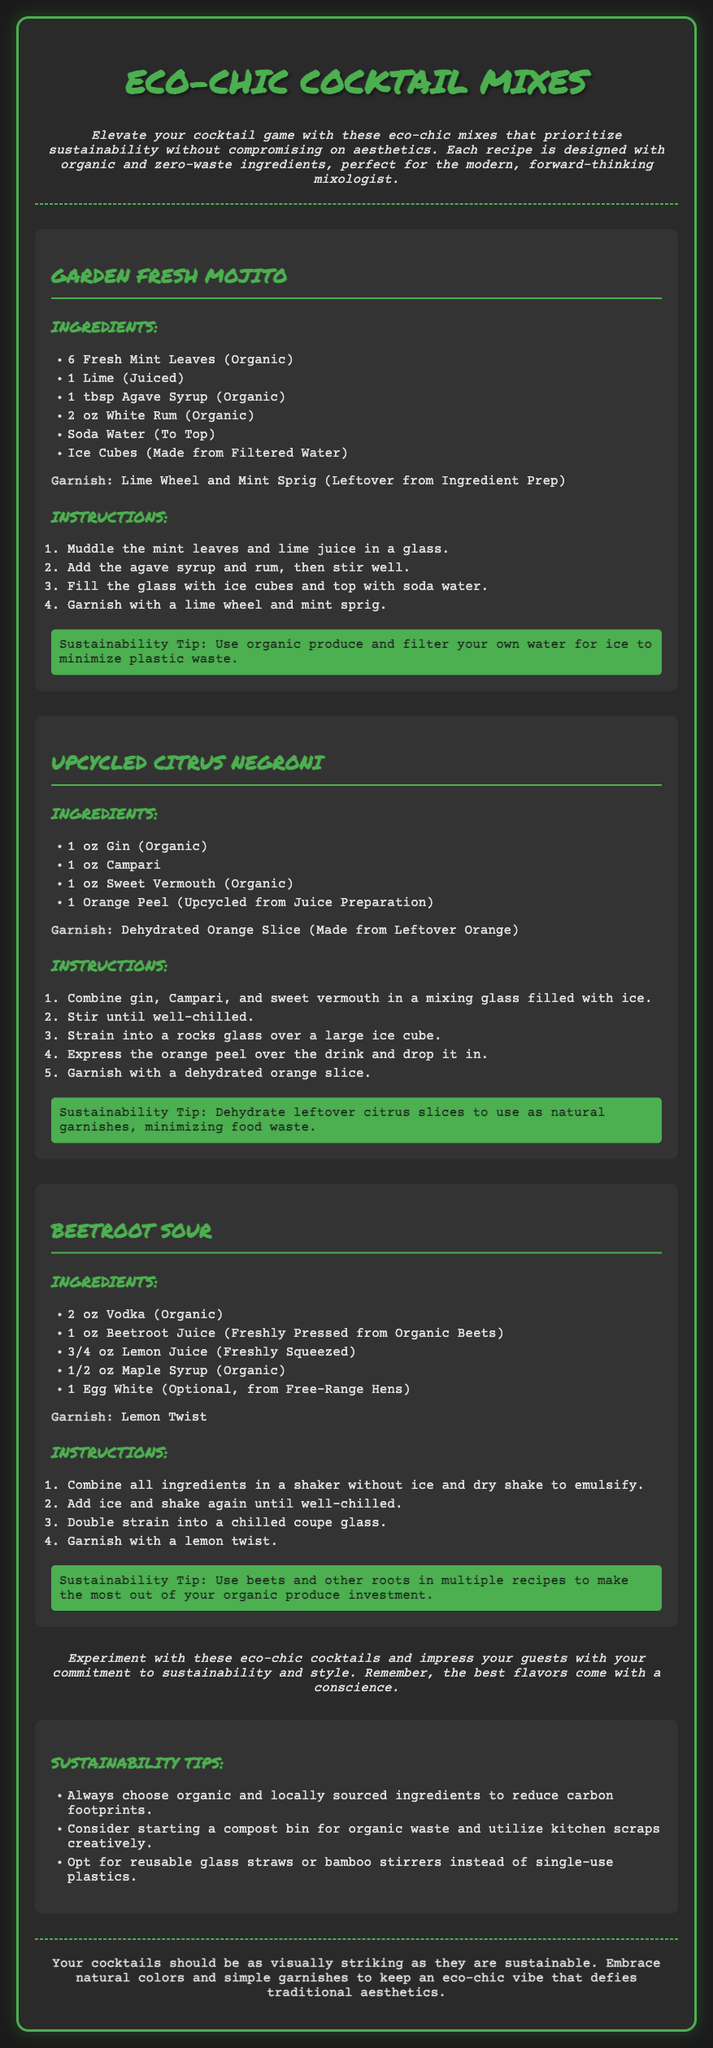what is the first cocktail recipe listed? The first cocktail recipe in the document is "Garden Fresh Mojito."
Answer: Garden Fresh Mojito how many ingredients are in the Upcycled Citrus Negroni? The Upcycled Citrus Negroni recipe lists four ingredients.
Answer: 4 what is the garnish for the Beetroot Sour? The garnish for the Beetroot Sour is a lemon twist.
Answer: Lemon Twist what sustainability tip is given for the Garden Fresh Mojito? The sustainability tip for the Garden Fresh Mojito suggests using organic produce and filtering water for ice to minimize plastic waste.
Answer: Use organic produce and filter your own water for ice to minimize plastic waste how should cocktails be visually presented according to the document? The document suggests that cocktails should embrace natural colors and simple garnishes for an eco-chic vibe.
Answer: Embrace natural colors and simple garnishes 